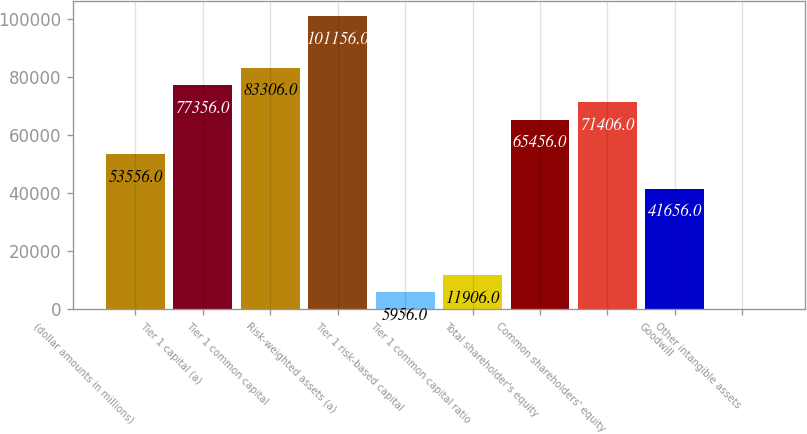Convert chart. <chart><loc_0><loc_0><loc_500><loc_500><bar_chart><fcel>(dollar amounts in millions)<fcel>Tier 1 capital (a)<fcel>Tier 1 common capital<fcel>Risk-weighted assets (a)<fcel>Tier 1 risk-based capital<fcel>Tier 1 common capital ratio<fcel>Total shareholder's equity<fcel>Common shareholders' equity<fcel>Goodwill<fcel>Other intangible assets<nl><fcel>53556<fcel>77356<fcel>83306<fcel>101156<fcel>5956<fcel>11906<fcel>65456<fcel>71406<fcel>41656<fcel>6<nl></chart> 